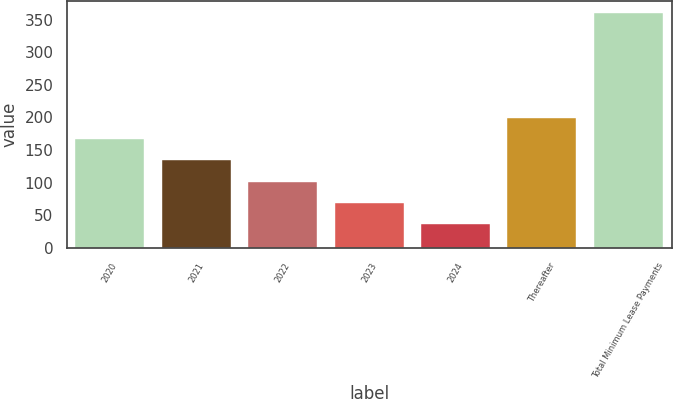<chart> <loc_0><loc_0><loc_500><loc_500><bar_chart><fcel>2020<fcel>2021<fcel>2022<fcel>2023<fcel>2024<fcel>Thereafter<fcel>Total Minimum Lease Payments<nl><fcel>166.26<fcel>133.87<fcel>101.48<fcel>69.09<fcel>36.7<fcel>198.65<fcel>360.6<nl></chart> 